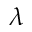Convert formula to latex. <formula><loc_0><loc_0><loc_500><loc_500>\lambda</formula> 